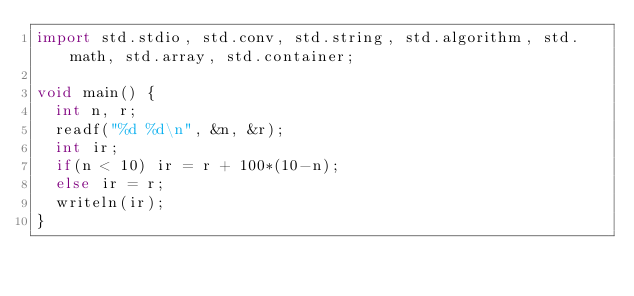Convert code to text. <code><loc_0><loc_0><loc_500><loc_500><_D_>import std.stdio, std.conv, std.string, std.algorithm, std.math, std.array, std.container;

void main() {
  int n, r;
  readf("%d %d\n", &n, &r);
  int ir;
  if(n < 10) ir = r + 100*(10-n);
  else ir = r;
  writeln(ir);
}

</code> 